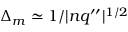<formula> <loc_0><loc_0><loc_500><loc_500>\Delta _ { m } \simeq 1 / | n q ^ { \prime \prime } | ^ { 1 / 2 }</formula> 